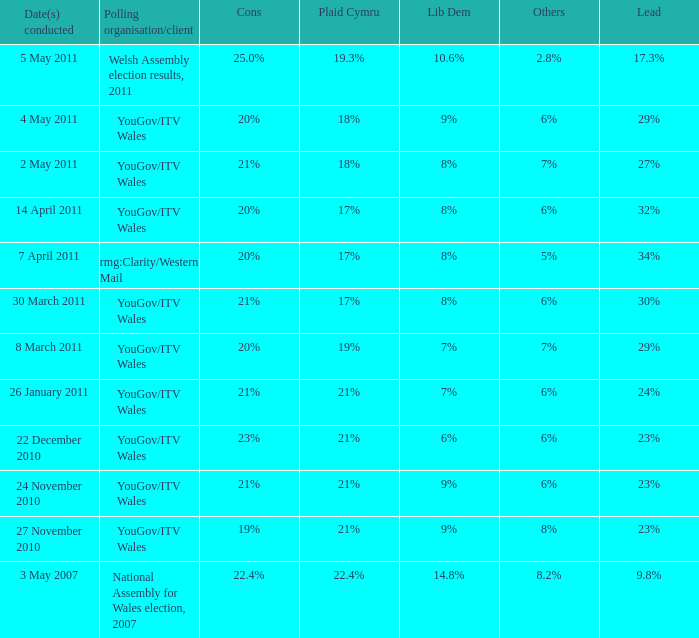What are the drawbacks for lib dem when they have 8% approval and a lead of 27%? 21%. 